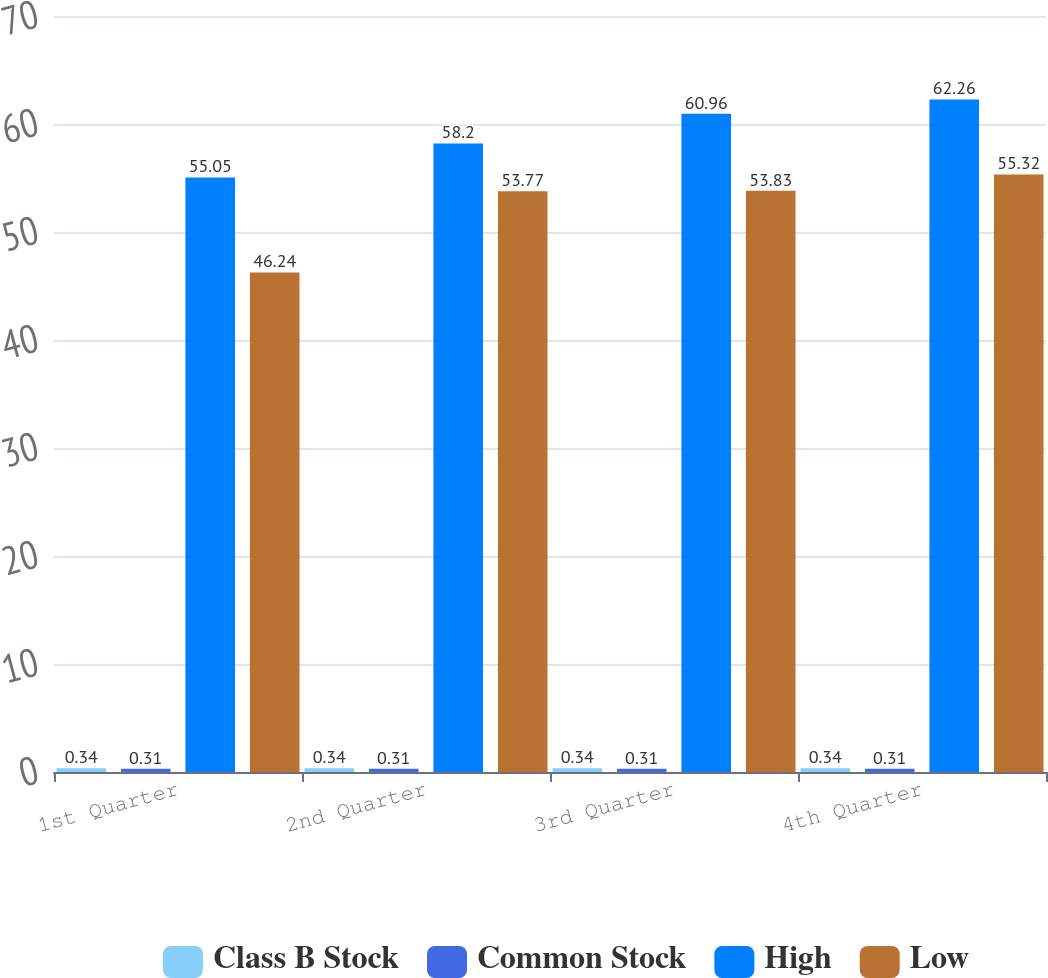Convert chart. <chart><loc_0><loc_0><loc_500><loc_500><stacked_bar_chart><ecel><fcel>1st Quarter<fcel>2nd Quarter<fcel>3rd Quarter<fcel>4th Quarter<nl><fcel>Class B Stock<fcel>0.34<fcel>0.34<fcel>0.34<fcel>0.34<nl><fcel>Common Stock<fcel>0.31<fcel>0.31<fcel>0.31<fcel>0.31<nl><fcel>High<fcel>55.05<fcel>58.2<fcel>60.96<fcel>62.26<nl><fcel>Low<fcel>46.24<fcel>53.77<fcel>53.83<fcel>55.32<nl></chart> 